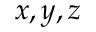<formula> <loc_0><loc_0><loc_500><loc_500>x , y , z</formula> 